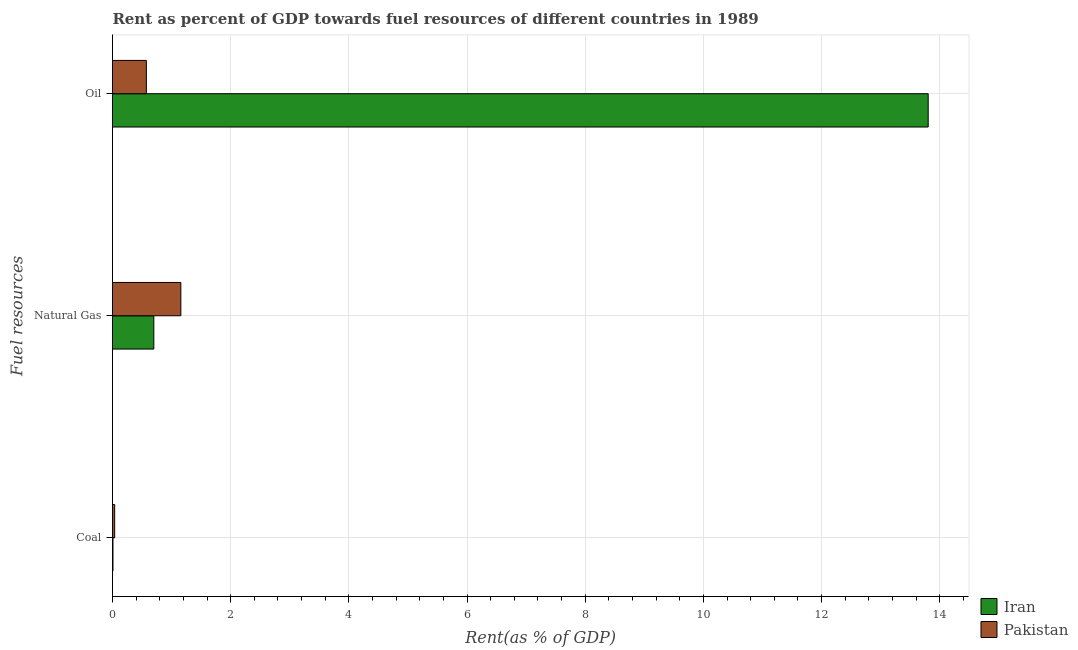How many different coloured bars are there?
Make the answer very short. 2. Are the number of bars on each tick of the Y-axis equal?
Make the answer very short. Yes. How many bars are there on the 2nd tick from the top?
Your answer should be compact. 2. What is the label of the 1st group of bars from the top?
Give a very brief answer. Oil. What is the rent towards natural gas in Iran?
Provide a succinct answer. 0.7. Across all countries, what is the maximum rent towards natural gas?
Offer a terse response. 1.16. Across all countries, what is the minimum rent towards coal?
Provide a succinct answer. 0.01. In which country was the rent towards natural gas maximum?
Provide a succinct answer. Pakistan. In which country was the rent towards natural gas minimum?
Keep it short and to the point. Iran. What is the total rent towards coal in the graph?
Ensure brevity in your answer.  0.04. What is the difference between the rent towards oil in Iran and that in Pakistan?
Your answer should be compact. 13.23. What is the difference between the rent towards coal in Pakistan and the rent towards oil in Iran?
Offer a terse response. -13.77. What is the average rent towards oil per country?
Provide a short and direct response. 7.19. What is the difference between the rent towards natural gas and rent towards oil in Pakistan?
Your answer should be compact. 0.58. In how many countries, is the rent towards natural gas greater than 13.2 %?
Ensure brevity in your answer.  0. What is the ratio of the rent towards coal in Iran to that in Pakistan?
Your answer should be very brief. 0.21. Is the rent towards natural gas in Iran less than that in Pakistan?
Provide a succinct answer. Yes. Is the difference between the rent towards coal in Iran and Pakistan greater than the difference between the rent towards oil in Iran and Pakistan?
Offer a very short reply. No. What is the difference between the highest and the second highest rent towards coal?
Give a very brief answer. 0.03. What is the difference between the highest and the lowest rent towards natural gas?
Offer a terse response. 0.46. What does the 1st bar from the top in Natural Gas represents?
Make the answer very short. Pakistan. What does the 1st bar from the bottom in Oil represents?
Give a very brief answer. Iran. Is it the case that in every country, the sum of the rent towards coal and rent towards natural gas is greater than the rent towards oil?
Keep it short and to the point. No. How many bars are there?
Make the answer very short. 6. Are all the bars in the graph horizontal?
Your answer should be very brief. Yes. Are the values on the major ticks of X-axis written in scientific E-notation?
Your answer should be very brief. No. Does the graph contain any zero values?
Provide a short and direct response. No. Does the graph contain grids?
Your response must be concise. Yes. Where does the legend appear in the graph?
Ensure brevity in your answer.  Bottom right. What is the title of the graph?
Provide a succinct answer. Rent as percent of GDP towards fuel resources of different countries in 1989. Does "Guyana" appear as one of the legend labels in the graph?
Give a very brief answer. No. What is the label or title of the X-axis?
Ensure brevity in your answer.  Rent(as % of GDP). What is the label or title of the Y-axis?
Offer a terse response. Fuel resources. What is the Rent(as % of GDP) of Iran in Coal?
Your response must be concise. 0.01. What is the Rent(as % of GDP) in Pakistan in Coal?
Provide a short and direct response. 0.04. What is the Rent(as % of GDP) of Iran in Natural Gas?
Your answer should be very brief. 0.7. What is the Rent(as % of GDP) in Pakistan in Natural Gas?
Provide a succinct answer. 1.16. What is the Rent(as % of GDP) of Iran in Oil?
Ensure brevity in your answer.  13.8. What is the Rent(as % of GDP) in Pakistan in Oil?
Provide a succinct answer. 0.57. Across all Fuel resources, what is the maximum Rent(as % of GDP) of Iran?
Your answer should be very brief. 13.8. Across all Fuel resources, what is the maximum Rent(as % of GDP) of Pakistan?
Keep it short and to the point. 1.16. Across all Fuel resources, what is the minimum Rent(as % of GDP) in Iran?
Keep it short and to the point. 0.01. Across all Fuel resources, what is the minimum Rent(as % of GDP) in Pakistan?
Provide a short and direct response. 0.04. What is the total Rent(as % of GDP) of Iran in the graph?
Provide a short and direct response. 14.51. What is the total Rent(as % of GDP) of Pakistan in the graph?
Your answer should be very brief. 1.77. What is the difference between the Rent(as % of GDP) in Iran in Coal and that in Natural Gas?
Your answer should be compact. -0.69. What is the difference between the Rent(as % of GDP) in Pakistan in Coal and that in Natural Gas?
Offer a very short reply. -1.12. What is the difference between the Rent(as % of GDP) of Iran in Coal and that in Oil?
Ensure brevity in your answer.  -13.8. What is the difference between the Rent(as % of GDP) in Pakistan in Coal and that in Oil?
Keep it short and to the point. -0.54. What is the difference between the Rent(as % of GDP) of Iran in Natural Gas and that in Oil?
Your answer should be very brief. -13.1. What is the difference between the Rent(as % of GDP) in Pakistan in Natural Gas and that in Oil?
Your answer should be compact. 0.58. What is the difference between the Rent(as % of GDP) in Iran in Coal and the Rent(as % of GDP) in Pakistan in Natural Gas?
Ensure brevity in your answer.  -1.15. What is the difference between the Rent(as % of GDP) in Iran in Coal and the Rent(as % of GDP) in Pakistan in Oil?
Ensure brevity in your answer.  -0.56. What is the difference between the Rent(as % of GDP) of Iran in Natural Gas and the Rent(as % of GDP) of Pakistan in Oil?
Your answer should be compact. 0.13. What is the average Rent(as % of GDP) in Iran per Fuel resources?
Give a very brief answer. 4.84. What is the average Rent(as % of GDP) in Pakistan per Fuel resources?
Offer a very short reply. 0.59. What is the difference between the Rent(as % of GDP) of Iran and Rent(as % of GDP) of Pakistan in Coal?
Provide a succinct answer. -0.03. What is the difference between the Rent(as % of GDP) in Iran and Rent(as % of GDP) in Pakistan in Natural Gas?
Give a very brief answer. -0.46. What is the difference between the Rent(as % of GDP) in Iran and Rent(as % of GDP) in Pakistan in Oil?
Provide a succinct answer. 13.23. What is the ratio of the Rent(as % of GDP) in Iran in Coal to that in Natural Gas?
Your answer should be very brief. 0.01. What is the ratio of the Rent(as % of GDP) in Pakistan in Coal to that in Natural Gas?
Make the answer very short. 0.03. What is the ratio of the Rent(as % of GDP) of Iran in Coal to that in Oil?
Your answer should be compact. 0. What is the ratio of the Rent(as % of GDP) of Pakistan in Coal to that in Oil?
Your response must be concise. 0.06. What is the ratio of the Rent(as % of GDP) of Iran in Natural Gas to that in Oil?
Keep it short and to the point. 0.05. What is the ratio of the Rent(as % of GDP) in Pakistan in Natural Gas to that in Oil?
Give a very brief answer. 2.02. What is the difference between the highest and the second highest Rent(as % of GDP) of Iran?
Keep it short and to the point. 13.1. What is the difference between the highest and the second highest Rent(as % of GDP) of Pakistan?
Your response must be concise. 0.58. What is the difference between the highest and the lowest Rent(as % of GDP) of Iran?
Give a very brief answer. 13.8. What is the difference between the highest and the lowest Rent(as % of GDP) of Pakistan?
Ensure brevity in your answer.  1.12. 